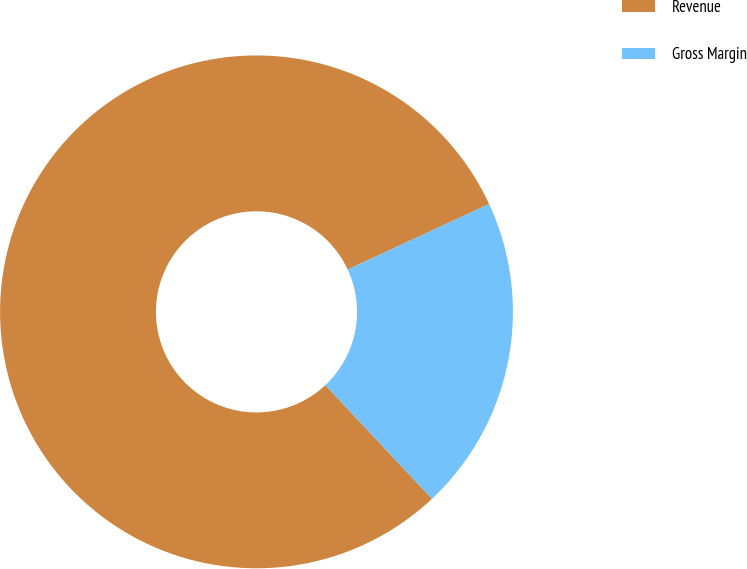Convert chart to OTSL. <chart><loc_0><loc_0><loc_500><loc_500><pie_chart><fcel>Revenue<fcel>Gross Margin<nl><fcel>80.09%<fcel>19.91%<nl></chart> 